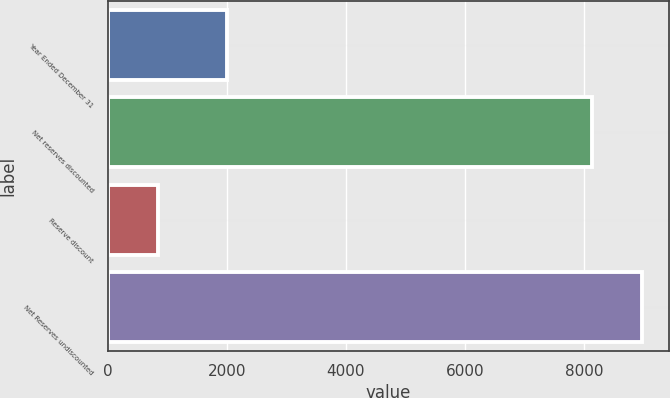Convert chart to OTSL. <chart><loc_0><loc_0><loc_500><loc_500><bar_chart><fcel>Year Ended December 31<fcel>Net reserves discounted<fcel>Reserve discount<fcel>Net Reserves undiscounted<nl><fcel>2008<fcel>8123<fcel>846<fcel>8969<nl></chart> 